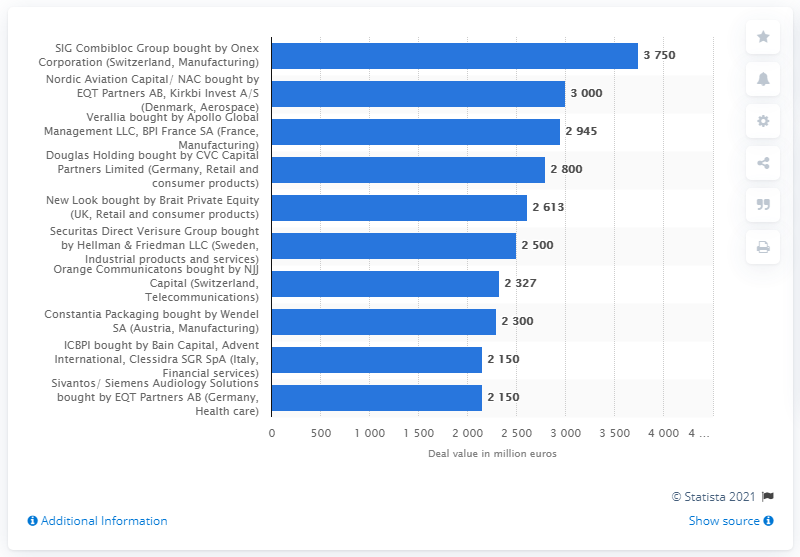Highlight a few significant elements in this photo. The deal value of SIG Combibloc Group was 3,750.. 